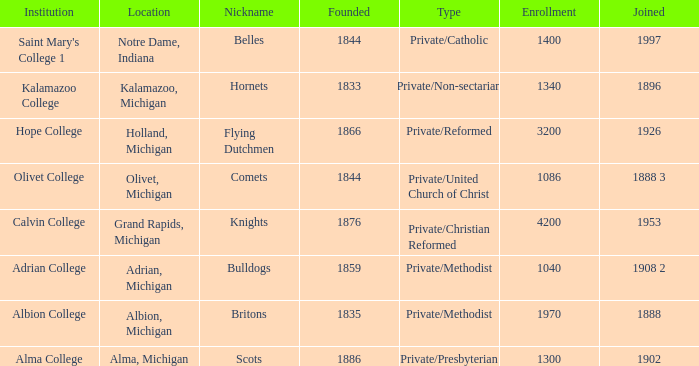Which categories fit under the institution calvin college? Private/Christian Reformed. 